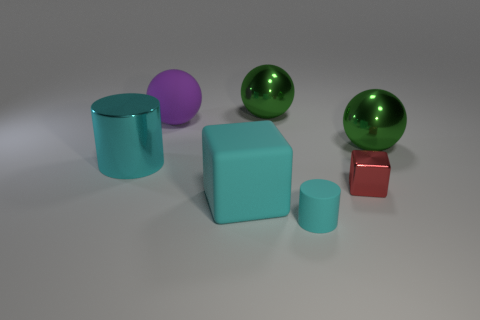Do the cylinder behind the red object and the tiny cyan matte thing have the same size?
Provide a short and direct response. No. Are there any small cylinders that have the same color as the matte sphere?
Provide a short and direct response. No. There is a cylinder in front of the rubber block; is there a metallic object that is behind it?
Offer a very short reply. Yes. Is there a large block made of the same material as the tiny cyan cylinder?
Your answer should be compact. Yes. There is a block left of the cyan cylinder on the right side of the cyan block; what is it made of?
Your response must be concise. Rubber. There is a thing that is both in front of the metal cylinder and behind the big cyan block; what material is it made of?
Your response must be concise. Metal. Is the number of spheres that are on the left side of the tiny red block the same as the number of large rubber objects?
Provide a short and direct response. Yes. How many cyan shiny things have the same shape as the tiny cyan matte object?
Give a very brief answer. 1. What is the size of the sphere that is in front of the big matte object behind the large cyan thing behind the tiny metal thing?
Your answer should be compact. Large. Is the material of the green object that is in front of the purple ball the same as the small red cube?
Your response must be concise. Yes. 